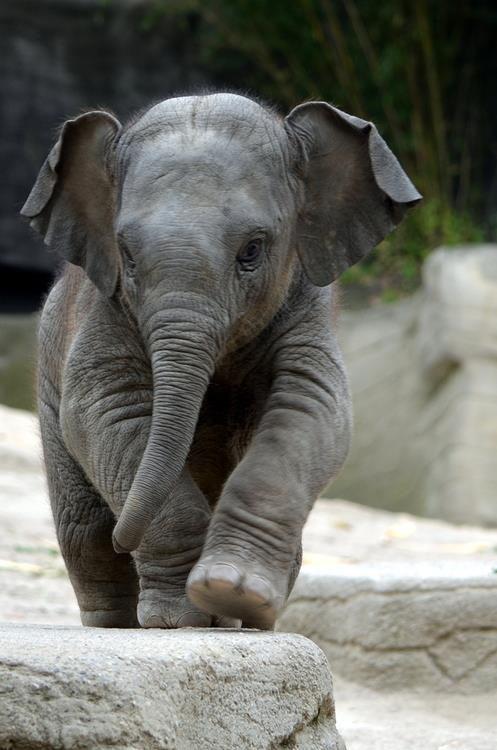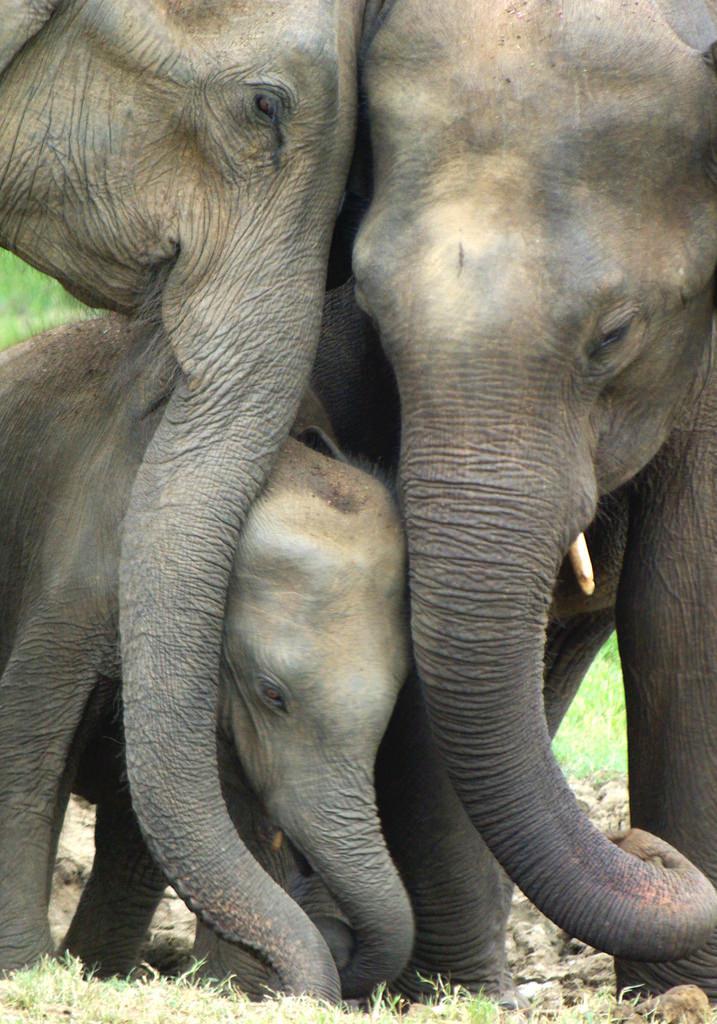The first image is the image on the left, the second image is the image on the right. Evaluate the accuracy of this statement regarding the images: "An image shows just one adult elephant interacting with a baby elephant on bright green grass.". Is it true? Answer yes or no. No. The first image is the image on the left, the second image is the image on the right. Analyze the images presented: Is the assertion "In each image, at the side of an adult elephant is a baby elephant, approximately tall enough to reach the underside of the adult's belly area." valid? Answer yes or no. No. 